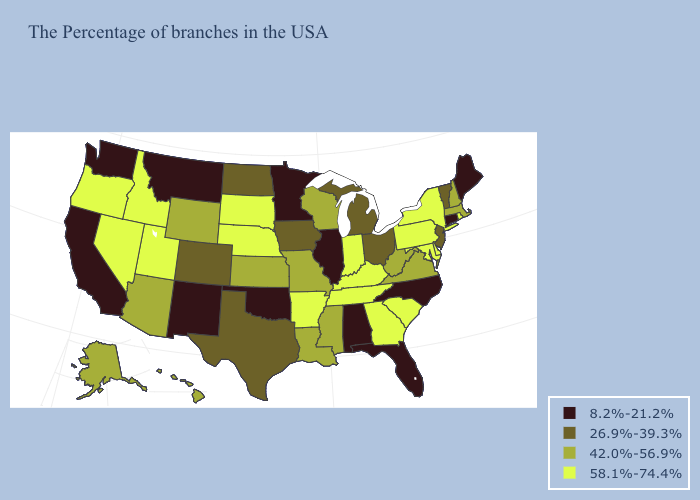What is the value of California?
Concise answer only. 8.2%-21.2%. What is the value of Wisconsin?
Quick response, please. 42.0%-56.9%. Does the first symbol in the legend represent the smallest category?
Be succinct. Yes. What is the highest value in states that border Connecticut?
Give a very brief answer. 58.1%-74.4%. What is the value of Illinois?
Give a very brief answer. 8.2%-21.2%. What is the value of New Jersey?
Short answer required. 26.9%-39.3%. Does Montana have the lowest value in the USA?
Keep it brief. Yes. Does Oregon have the lowest value in the West?
Keep it brief. No. Name the states that have a value in the range 26.9%-39.3%?
Be succinct. Vermont, New Jersey, Ohio, Michigan, Iowa, Texas, North Dakota, Colorado. Name the states that have a value in the range 58.1%-74.4%?
Give a very brief answer. Rhode Island, New York, Delaware, Maryland, Pennsylvania, South Carolina, Georgia, Kentucky, Indiana, Tennessee, Arkansas, Nebraska, South Dakota, Utah, Idaho, Nevada, Oregon. Among the states that border Tennessee , does Georgia have the highest value?
Be succinct. Yes. Does Maine have the highest value in the USA?
Give a very brief answer. No. Which states hav the highest value in the West?
Be succinct. Utah, Idaho, Nevada, Oregon. Which states have the highest value in the USA?
Give a very brief answer. Rhode Island, New York, Delaware, Maryland, Pennsylvania, South Carolina, Georgia, Kentucky, Indiana, Tennessee, Arkansas, Nebraska, South Dakota, Utah, Idaho, Nevada, Oregon. Among the states that border Missouri , which have the lowest value?
Be succinct. Illinois, Oklahoma. 